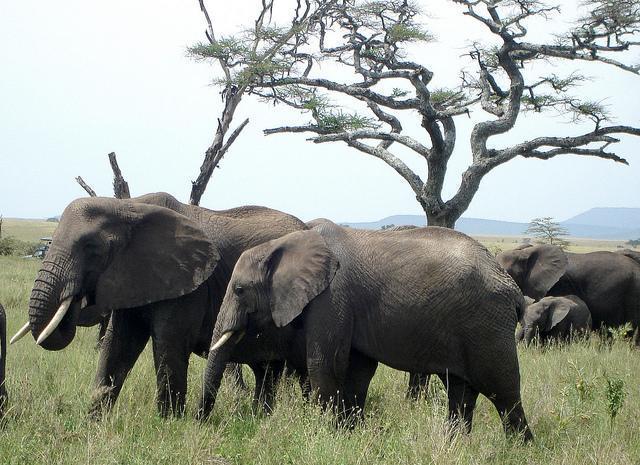How many babies are present?
Give a very brief answer. 1. How many elephants are in the photo?
Give a very brief answer. 4. 